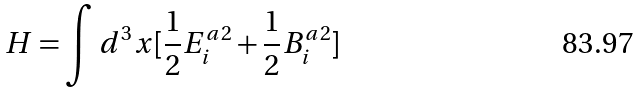Convert formula to latex. <formula><loc_0><loc_0><loc_500><loc_500>H = \int d ^ { 3 } x [ \frac { 1 } { 2 } E _ { i } ^ { a 2 } + \frac { 1 } { 2 } B _ { i } ^ { a 2 } ]</formula> 